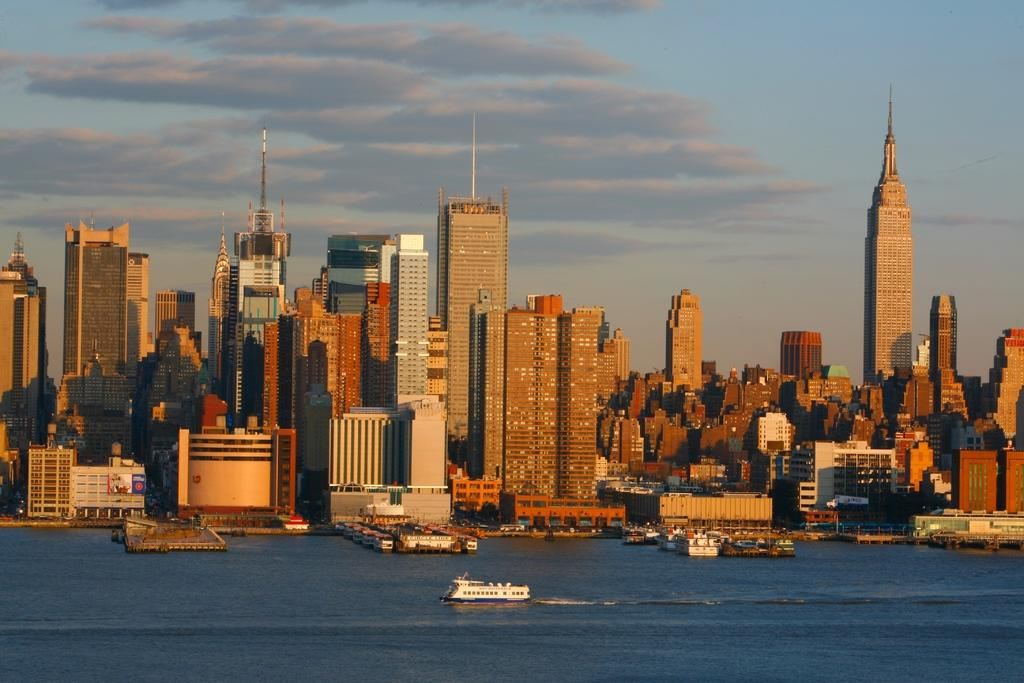What is the main subject of the image? The main subject of the image is a boat. Where is the boat located in the image? The boat is on the water. What is the color of the boat? The boat is white in color. What can be seen in the background of the image? There are buildings in the background of the image. What colors are the buildings? The buildings are in brown and white colors. How does the mist affect the boat's journey in the image? There is no mention of mist in the image, so we cannot determine its effect on the boat's journey. 